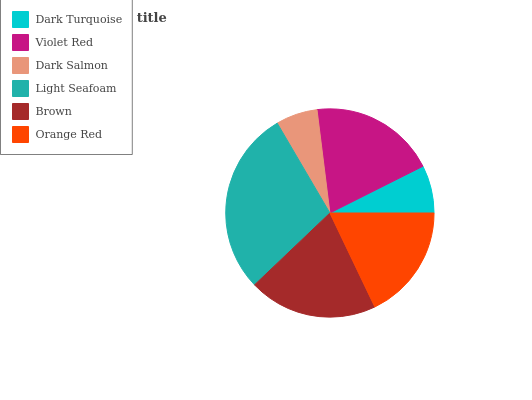Is Dark Salmon the minimum?
Answer yes or no. Yes. Is Light Seafoam the maximum?
Answer yes or no. Yes. Is Violet Red the minimum?
Answer yes or no. No. Is Violet Red the maximum?
Answer yes or no. No. Is Violet Red greater than Dark Turquoise?
Answer yes or no. Yes. Is Dark Turquoise less than Violet Red?
Answer yes or no. Yes. Is Dark Turquoise greater than Violet Red?
Answer yes or no. No. Is Violet Red less than Dark Turquoise?
Answer yes or no. No. Is Violet Red the high median?
Answer yes or no. Yes. Is Orange Red the low median?
Answer yes or no. Yes. Is Brown the high median?
Answer yes or no. No. Is Light Seafoam the low median?
Answer yes or no. No. 